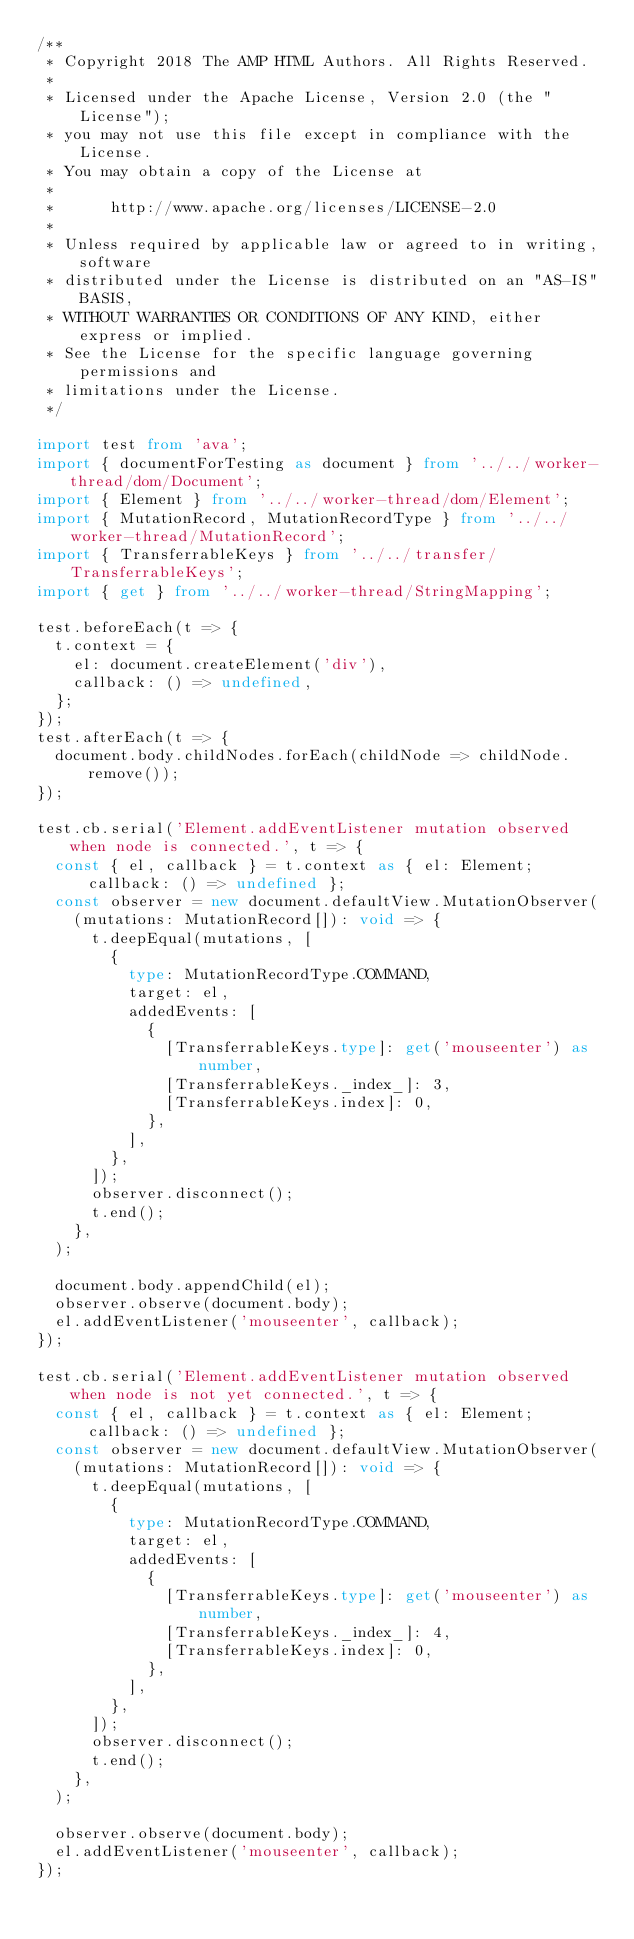<code> <loc_0><loc_0><loc_500><loc_500><_TypeScript_>/**
 * Copyright 2018 The AMP HTML Authors. All Rights Reserved.
 *
 * Licensed under the Apache License, Version 2.0 (the "License");
 * you may not use this file except in compliance with the License.
 * You may obtain a copy of the License at
 *
 *      http://www.apache.org/licenses/LICENSE-2.0
 *
 * Unless required by applicable law or agreed to in writing, software
 * distributed under the License is distributed on an "AS-IS" BASIS,
 * WITHOUT WARRANTIES OR CONDITIONS OF ANY KIND, either express or implied.
 * See the License for the specific language governing permissions and
 * limitations under the License.
 */

import test from 'ava';
import { documentForTesting as document } from '../../worker-thread/dom/Document';
import { Element } from '../../worker-thread/dom/Element';
import { MutationRecord, MutationRecordType } from '../../worker-thread/MutationRecord';
import { TransferrableKeys } from '../../transfer/TransferrableKeys';
import { get } from '../../worker-thread/StringMapping';

test.beforeEach(t => {
  t.context = {
    el: document.createElement('div'),
    callback: () => undefined,
  };
});
test.afterEach(t => {
  document.body.childNodes.forEach(childNode => childNode.remove());
});

test.cb.serial('Element.addEventListener mutation observed when node is connected.', t => {
  const { el, callback } = t.context as { el: Element; callback: () => undefined };
  const observer = new document.defaultView.MutationObserver(
    (mutations: MutationRecord[]): void => {
      t.deepEqual(mutations, [
        {
          type: MutationRecordType.COMMAND,
          target: el,
          addedEvents: [
            {
              [TransferrableKeys.type]: get('mouseenter') as number,
              [TransferrableKeys._index_]: 3,
              [TransferrableKeys.index]: 0,
            },
          ],
        },
      ]);
      observer.disconnect();
      t.end();
    },
  );

  document.body.appendChild(el);
  observer.observe(document.body);
  el.addEventListener('mouseenter', callback);
});

test.cb.serial('Element.addEventListener mutation observed when node is not yet connected.', t => {
  const { el, callback } = t.context as { el: Element; callback: () => undefined };
  const observer = new document.defaultView.MutationObserver(
    (mutations: MutationRecord[]): void => {
      t.deepEqual(mutations, [
        {
          type: MutationRecordType.COMMAND,
          target: el,
          addedEvents: [
            {
              [TransferrableKeys.type]: get('mouseenter') as number,
              [TransferrableKeys._index_]: 4,
              [TransferrableKeys.index]: 0,
            },
          ],
        },
      ]);
      observer.disconnect();
      t.end();
    },
  );

  observer.observe(document.body);
  el.addEventListener('mouseenter', callback);
});
</code> 